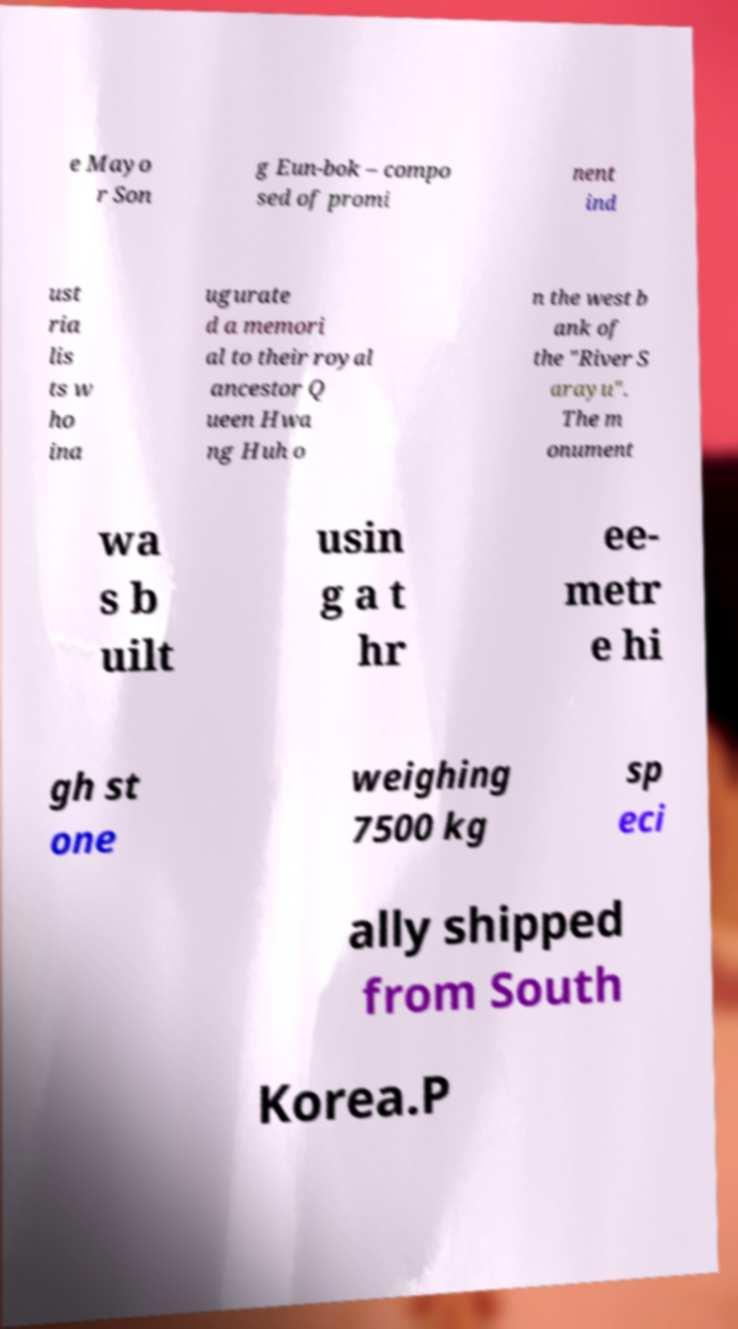Please read and relay the text visible in this image. What does it say? e Mayo r Son g Eun-bok – compo sed of promi nent ind ust ria lis ts w ho ina ugurate d a memori al to their royal ancestor Q ueen Hwa ng Huh o n the west b ank of the "River S arayu". The m onument wa s b uilt usin g a t hr ee- metr e hi gh st one weighing 7500 kg sp eci ally shipped from South Korea.P 